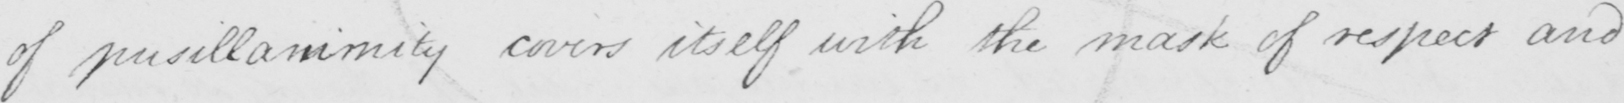What is written in this line of handwriting? of pusillammity covers itself with the mask of respect and 